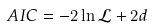<formula> <loc_0><loc_0><loc_500><loc_500>A I C = - 2 \ln { \mathcal { L } } + 2 d</formula> 